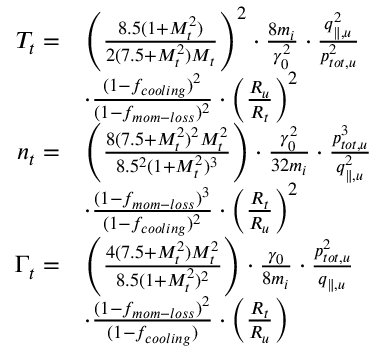<formula> <loc_0><loc_0><loc_500><loc_500>\begin{array} { r l } { T _ { t } = } & { \left ( \frac { 8 . 5 ( 1 + M _ { t } ^ { 2 } ) } { 2 ( 7 . 5 + M _ { t } ^ { 2 } ) M _ { t } } \right ) ^ { 2 } \cdot \frac { 8 m _ { i } } { \gamma _ { 0 } ^ { 2 } } \cdot \frac { q _ { \| , u } ^ { 2 } } { p _ { t o t , u } ^ { 2 } } } \\ & { \cdot \frac { ( 1 - f _ { c o o l i n g } ) ^ { 2 } } { ( 1 - f _ { m o m - l o s s } ) ^ { 2 } } \cdot \left ( \frac { R _ { u } } { R _ { t } } \right ) ^ { 2 } } \\ { n _ { t } = } & { \left ( \frac { 8 ( 7 . 5 + M _ { t } ^ { 2 } ) ^ { 2 } M _ { t } ^ { 2 } } { 8 . 5 ^ { 2 } ( 1 + M _ { t } ^ { 2 } ) ^ { 3 } } \right ) \cdot \frac { \gamma _ { 0 } ^ { 2 } } { 3 2 m _ { i } } \cdot \frac { p _ { t o t , u } ^ { 3 } } { q _ { \| , u } ^ { 2 } } } \\ & { \cdot \frac { ( 1 - f _ { m o m - l o s s } ) ^ { 3 } } { ( 1 - f _ { c o o l i n g } ) ^ { 2 } } \cdot \left ( \frac { R _ { t } } { R _ { u } } \right ) ^ { 2 } } \\ { \Gamma _ { t } = } & { \left ( \frac { 4 ( 7 . 5 + M _ { t } ^ { 2 } ) M _ { t } ^ { 2 } } { 8 . 5 ( 1 + M _ { t } ^ { 2 } ) ^ { 2 } } \right ) \cdot \frac { \gamma _ { 0 } } { 8 m _ { i } } \cdot \frac { p _ { t o t , u } ^ { 2 } } { q _ { \| , u } } } \\ & { \cdot \frac { ( 1 - f _ { m o m - l o s s } ) ^ { 2 } } { ( 1 - f _ { c o o l i n g } ) } \cdot \left ( \frac { R _ { t } } { R _ { u } } \right ) } \end{array}</formula> 